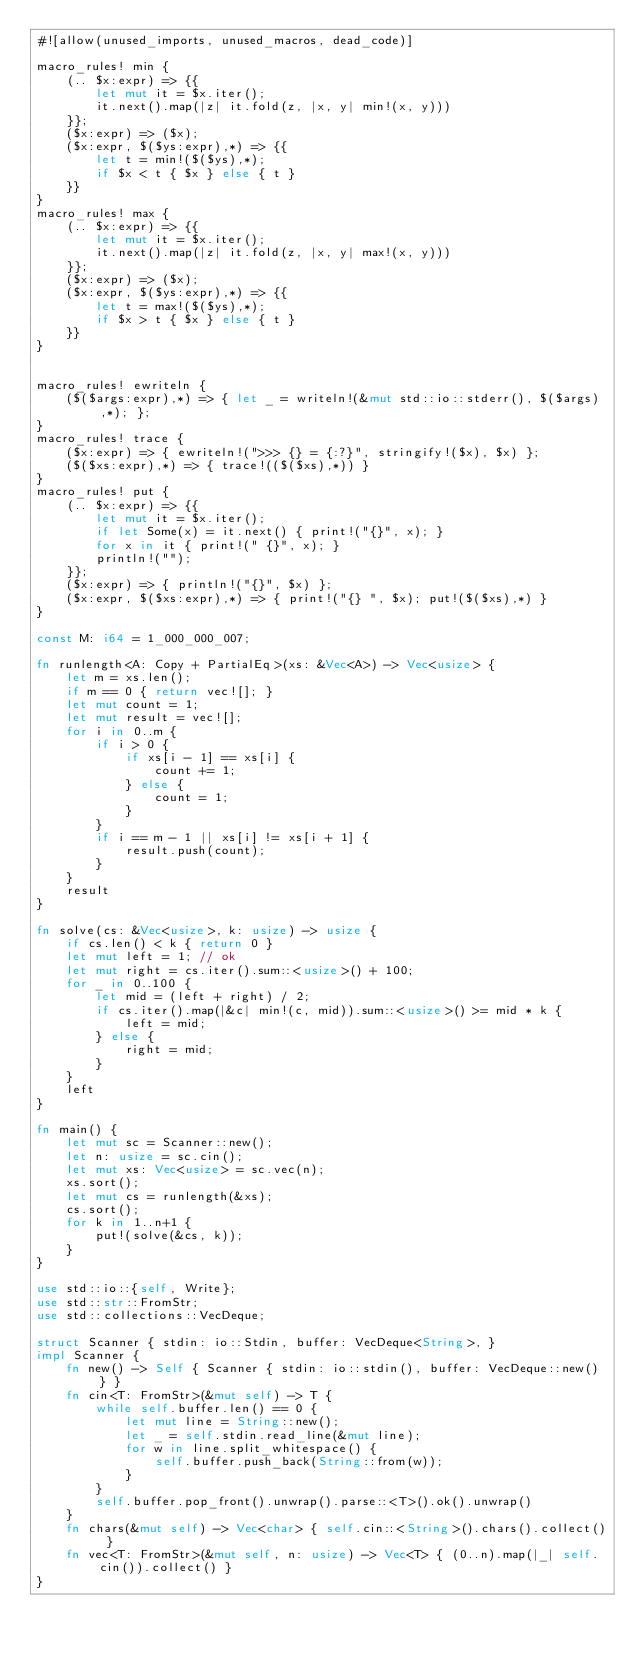Convert code to text. <code><loc_0><loc_0><loc_500><loc_500><_Rust_>#![allow(unused_imports, unused_macros, dead_code)]

macro_rules! min {
    (.. $x:expr) => {{
        let mut it = $x.iter();
        it.next().map(|z| it.fold(z, |x, y| min!(x, y)))
    }};
    ($x:expr) => ($x);
    ($x:expr, $($ys:expr),*) => {{
        let t = min!($($ys),*);
        if $x < t { $x } else { t }
    }}
}
macro_rules! max {
    (.. $x:expr) => {{
        let mut it = $x.iter();
        it.next().map(|z| it.fold(z, |x, y| max!(x, y)))
    }};
    ($x:expr) => ($x);
    ($x:expr, $($ys:expr),*) => {{
        let t = max!($($ys),*);
        if $x > t { $x } else { t }
    }}
}


macro_rules! ewriteln {
    ($($args:expr),*) => { let _ = writeln!(&mut std::io::stderr(), $($args),*); };
}
macro_rules! trace {
    ($x:expr) => { ewriteln!(">>> {} = {:?}", stringify!($x), $x) };
    ($($xs:expr),*) => { trace!(($($xs),*)) }
}
macro_rules! put {
    (.. $x:expr) => {{
        let mut it = $x.iter();
        if let Some(x) = it.next() { print!("{}", x); }
        for x in it { print!(" {}", x); }
        println!("");
    }};
    ($x:expr) => { println!("{}", $x) };
    ($x:expr, $($xs:expr),*) => { print!("{} ", $x); put!($($xs),*) }
}

const M: i64 = 1_000_000_007;

fn runlength<A: Copy + PartialEq>(xs: &Vec<A>) -> Vec<usize> {
    let m = xs.len();
    if m == 0 { return vec![]; }
    let mut count = 1;
    let mut result = vec![];
    for i in 0..m {
        if i > 0 {
            if xs[i - 1] == xs[i] {
                count += 1;
            } else {
                count = 1;
            }
        }
        if i == m - 1 || xs[i] != xs[i + 1] {
            result.push(count);
        }
    }
    result
}

fn solve(cs: &Vec<usize>, k: usize) -> usize {
    if cs.len() < k { return 0 }
    let mut left = 1; // ok
    let mut right = cs.iter().sum::<usize>() + 100;
    for _ in 0..100 {
        let mid = (left + right) / 2;
        if cs.iter().map(|&c| min!(c, mid)).sum::<usize>() >= mid * k {
            left = mid;
        } else {
            right = mid;
        }
    }
    left
}

fn main() {
    let mut sc = Scanner::new();
    let n: usize = sc.cin();
    let mut xs: Vec<usize> = sc.vec(n);
    xs.sort();
    let mut cs = runlength(&xs);
    cs.sort();
    for k in 1..n+1 {
        put!(solve(&cs, k));
    }
}

use std::io::{self, Write};
use std::str::FromStr;
use std::collections::VecDeque;

struct Scanner { stdin: io::Stdin, buffer: VecDeque<String>, }
impl Scanner {
    fn new() -> Self { Scanner { stdin: io::stdin(), buffer: VecDeque::new() } }
    fn cin<T: FromStr>(&mut self) -> T {
        while self.buffer.len() == 0 {
            let mut line = String::new();
            let _ = self.stdin.read_line(&mut line);
            for w in line.split_whitespace() {
                self.buffer.push_back(String::from(w));
            }
        }
        self.buffer.pop_front().unwrap().parse::<T>().ok().unwrap()
    }
    fn chars(&mut self) -> Vec<char> { self.cin::<String>().chars().collect() }
    fn vec<T: FromStr>(&mut self, n: usize) -> Vec<T> { (0..n).map(|_| self.cin()).collect() }
}
</code> 